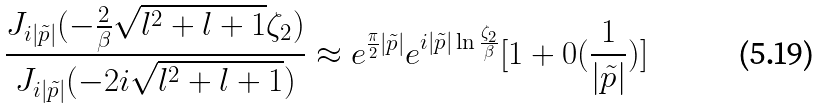<formula> <loc_0><loc_0><loc_500><loc_500>\frac { J _ { i | \tilde { p } | } ( - \frac { 2 } { \beta } \sqrt { l ^ { 2 } + l + 1 } \zeta _ { 2 } ) } { J _ { i | \tilde { p } | } ( - 2 i \sqrt { l ^ { 2 } + l + 1 } ) } \approx e ^ { \frac { \pi } { 2 } | \tilde { p } | } e ^ { i | \tilde { p } | \ln \frac { \zeta _ { 2 } } { \beta } } [ 1 + 0 ( \frac { 1 } { | \tilde { p } | } ) ]</formula> 